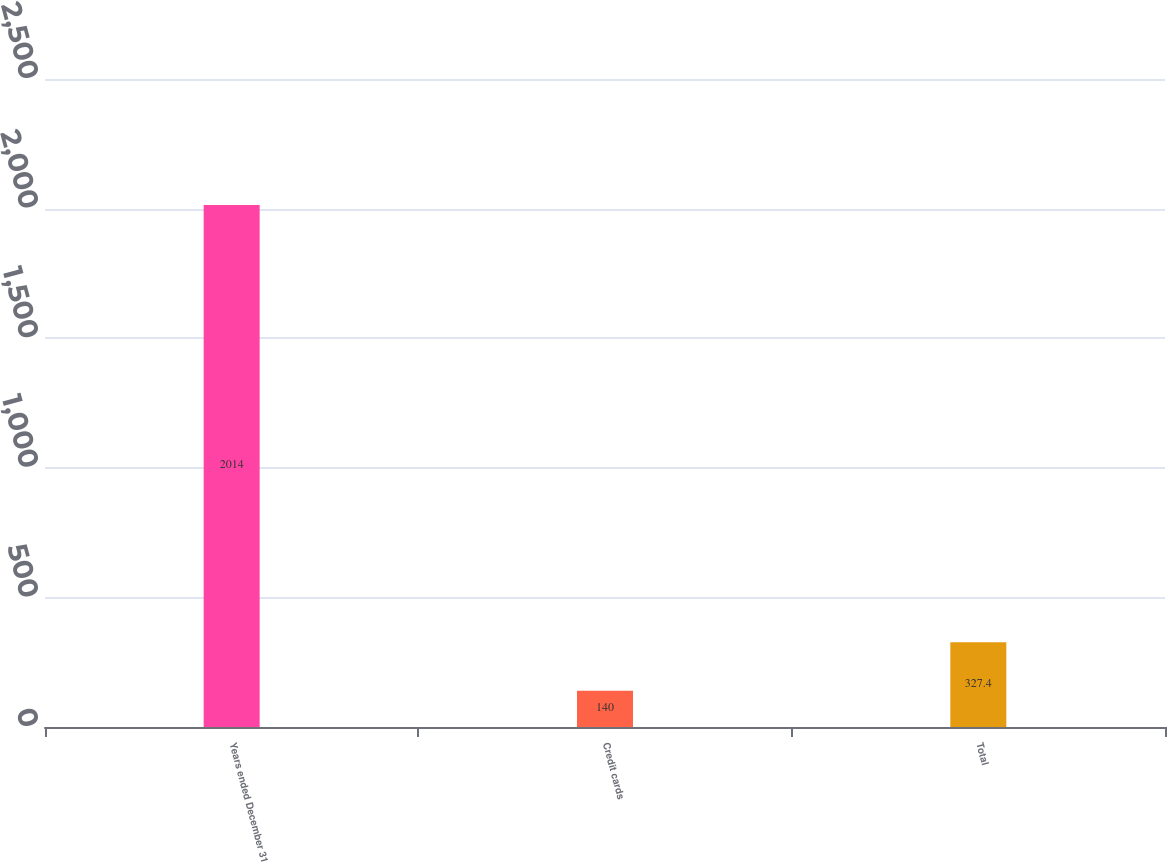Convert chart to OTSL. <chart><loc_0><loc_0><loc_500><loc_500><bar_chart><fcel>Years ended December 31<fcel>Credit cards<fcel>Total<nl><fcel>2014<fcel>140<fcel>327.4<nl></chart> 